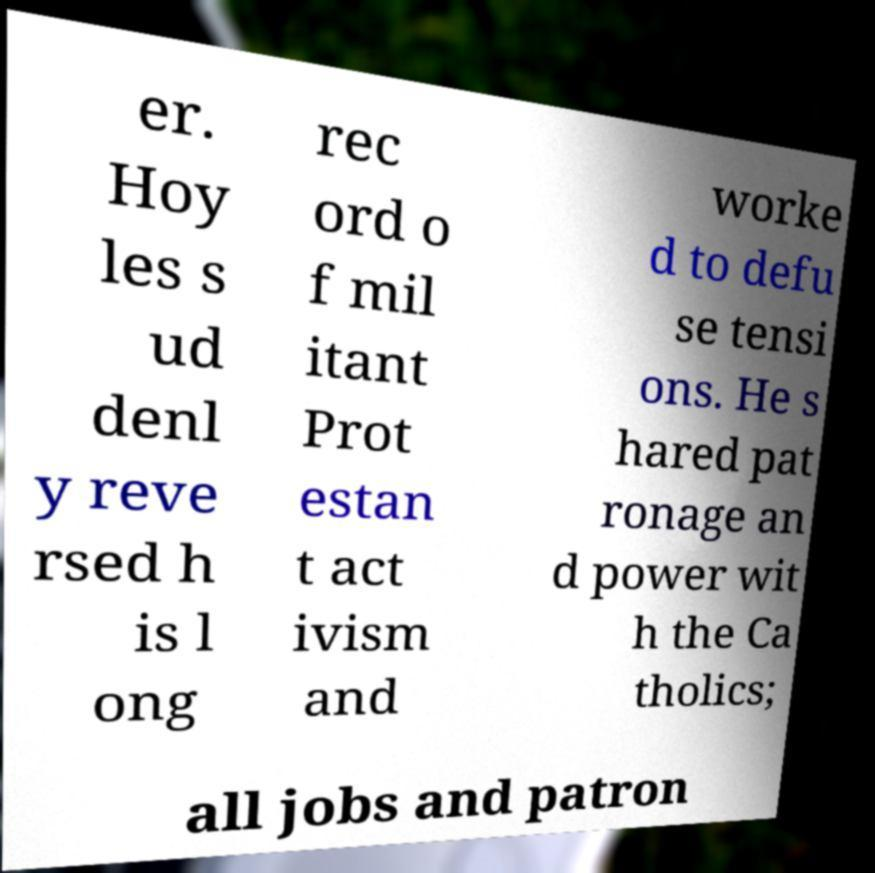There's text embedded in this image that I need extracted. Can you transcribe it verbatim? er. Hoy les s ud denl y reve rsed h is l ong rec ord o f mil itant Prot estan t act ivism and worke d to defu se tensi ons. He s hared pat ronage an d power wit h the Ca tholics; all jobs and patron 